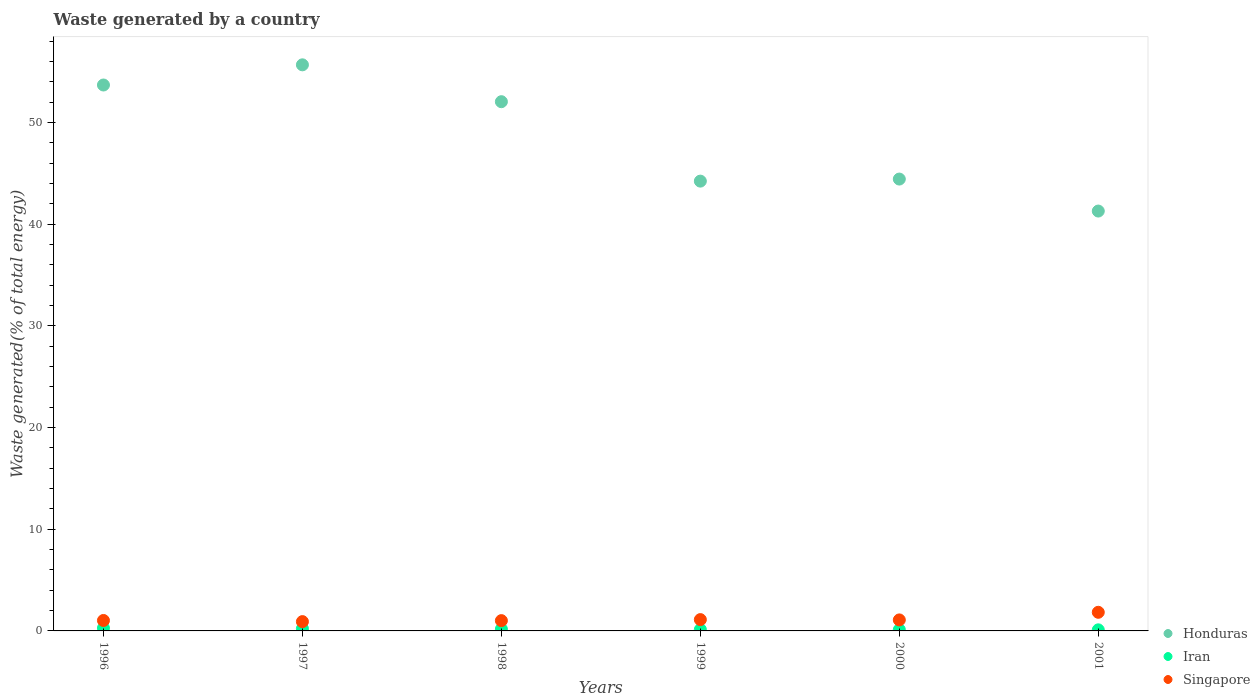How many different coloured dotlines are there?
Keep it short and to the point. 3. Is the number of dotlines equal to the number of legend labels?
Offer a very short reply. Yes. What is the total waste generated in Honduras in 2000?
Offer a terse response. 44.44. Across all years, what is the maximum total waste generated in Singapore?
Give a very brief answer. 1.83. Across all years, what is the minimum total waste generated in Singapore?
Offer a terse response. 0.91. In which year was the total waste generated in Singapore maximum?
Make the answer very short. 2001. In which year was the total waste generated in Singapore minimum?
Offer a terse response. 1997. What is the total total waste generated in Singapore in the graph?
Your answer should be compact. 6.98. What is the difference between the total waste generated in Honduras in 1997 and that in 1998?
Make the answer very short. 3.63. What is the difference between the total waste generated in Singapore in 1998 and the total waste generated in Honduras in 1996?
Your response must be concise. -52.67. What is the average total waste generated in Singapore per year?
Provide a short and direct response. 1.16. In the year 2000, what is the difference between the total waste generated in Singapore and total waste generated in Honduras?
Your answer should be very brief. -43.35. What is the ratio of the total waste generated in Singapore in 1997 to that in 2001?
Make the answer very short. 0.5. What is the difference between the highest and the second highest total waste generated in Singapore?
Your answer should be compact. 0.72. What is the difference between the highest and the lowest total waste generated in Iran?
Ensure brevity in your answer.  0.17. Is the sum of the total waste generated in Honduras in 1996 and 1998 greater than the maximum total waste generated in Singapore across all years?
Keep it short and to the point. Yes. Is it the case that in every year, the sum of the total waste generated in Honduras and total waste generated in Singapore  is greater than the total waste generated in Iran?
Provide a short and direct response. Yes. Does the total waste generated in Honduras monotonically increase over the years?
Provide a succinct answer. No. Is the total waste generated in Singapore strictly less than the total waste generated in Iran over the years?
Give a very brief answer. No. Are the values on the major ticks of Y-axis written in scientific E-notation?
Provide a succinct answer. No. How are the legend labels stacked?
Give a very brief answer. Vertical. What is the title of the graph?
Give a very brief answer. Waste generated by a country. What is the label or title of the X-axis?
Your answer should be compact. Years. What is the label or title of the Y-axis?
Give a very brief answer. Waste generated(% of total energy). What is the Waste generated(% of total energy) in Honduras in 1996?
Give a very brief answer. 53.69. What is the Waste generated(% of total energy) of Iran in 1996?
Offer a very short reply. 0.28. What is the Waste generated(% of total energy) in Singapore in 1996?
Your response must be concise. 1.03. What is the Waste generated(% of total energy) of Honduras in 1997?
Ensure brevity in your answer.  55.67. What is the Waste generated(% of total energy) in Iran in 1997?
Offer a terse response. 0.22. What is the Waste generated(% of total energy) of Singapore in 1997?
Make the answer very short. 0.91. What is the Waste generated(% of total energy) of Honduras in 1998?
Provide a succinct answer. 52.04. What is the Waste generated(% of total energy) in Iran in 1998?
Provide a short and direct response. 0.18. What is the Waste generated(% of total energy) of Singapore in 1998?
Your answer should be compact. 1.01. What is the Waste generated(% of total energy) in Honduras in 1999?
Ensure brevity in your answer.  44.23. What is the Waste generated(% of total energy) in Iran in 1999?
Your answer should be very brief. 0.14. What is the Waste generated(% of total energy) in Singapore in 1999?
Provide a short and direct response. 1.11. What is the Waste generated(% of total energy) of Honduras in 2000?
Provide a short and direct response. 44.44. What is the Waste generated(% of total energy) in Iran in 2000?
Your answer should be very brief. 0.12. What is the Waste generated(% of total energy) in Singapore in 2000?
Your answer should be very brief. 1.08. What is the Waste generated(% of total energy) in Honduras in 2001?
Provide a short and direct response. 41.29. What is the Waste generated(% of total energy) of Iran in 2001?
Keep it short and to the point. 0.11. What is the Waste generated(% of total energy) of Singapore in 2001?
Offer a terse response. 1.83. Across all years, what is the maximum Waste generated(% of total energy) of Honduras?
Provide a succinct answer. 55.67. Across all years, what is the maximum Waste generated(% of total energy) of Iran?
Make the answer very short. 0.28. Across all years, what is the maximum Waste generated(% of total energy) of Singapore?
Give a very brief answer. 1.83. Across all years, what is the minimum Waste generated(% of total energy) of Honduras?
Offer a very short reply. 41.29. Across all years, what is the minimum Waste generated(% of total energy) of Iran?
Make the answer very short. 0.11. Across all years, what is the minimum Waste generated(% of total energy) in Singapore?
Provide a short and direct response. 0.91. What is the total Waste generated(% of total energy) in Honduras in the graph?
Make the answer very short. 291.36. What is the total Waste generated(% of total energy) in Iran in the graph?
Provide a short and direct response. 1.05. What is the total Waste generated(% of total energy) of Singapore in the graph?
Your answer should be compact. 6.98. What is the difference between the Waste generated(% of total energy) in Honduras in 1996 and that in 1997?
Offer a terse response. -1.98. What is the difference between the Waste generated(% of total energy) in Iran in 1996 and that in 1997?
Give a very brief answer. 0.05. What is the difference between the Waste generated(% of total energy) in Singapore in 1996 and that in 1997?
Keep it short and to the point. 0.11. What is the difference between the Waste generated(% of total energy) in Honduras in 1996 and that in 1998?
Provide a short and direct response. 1.64. What is the difference between the Waste generated(% of total energy) of Iran in 1996 and that in 1998?
Your answer should be compact. 0.1. What is the difference between the Waste generated(% of total energy) of Singapore in 1996 and that in 1998?
Give a very brief answer. 0.02. What is the difference between the Waste generated(% of total energy) of Honduras in 1996 and that in 1999?
Provide a short and direct response. 9.45. What is the difference between the Waste generated(% of total energy) of Iran in 1996 and that in 1999?
Make the answer very short. 0.14. What is the difference between the Waste generated(% of total energy) in Singapore in 1996 and that in 1999?
Provide a short and direct response. -0.09. What is the difference between the Waste generated(% of total energy) in Honduras in 1996 and that in 2000?
Provide a short and direct response. 9.25. What is the difference between the Waste generated(% of total energy) in Iran in 1996 and that in 2000?
Your answer should be compact. 0.15. What is the difference between the Waste generated(% of total energy) of Singapore in 1996 and that in 2000?
Keep it short and to the point. -0.06. What is the difference between the Waste generated(% of total energy) in Honduras in 1996 and that in 2001?
Your response must be concise. 12.4. What is the difference between the Waste generated(% of total energy) in Iran in 1996 and that in 2001?
Provide a short and direct response. 0.17. What is the difference between the Waste generated(% of total energy) in Singapore in 1996 and that in 2001?
Provide a short and direct response. -0.8. What is the difference between the Waste generated(% of total energy) of Honduras in 1997 and that in 1998?
Ensure brevity in your answer.  3.63. What is the difference between the Waste generated(% of total energy) of Iran in 1997 and that in 1998?
Your answer should be compact. 0.05. What is the difference between the Waste generated(% of total energy) in Singapore in 1997 and that in 1998?
Provide a short and direct response. -0.1. What is the difference between the Waste generated(% of total energy) of Honduras in 1997 and that in 1999?
Keep it short and to the point. 11.44. What is the difference between the Waste generated(% of total energy) of Iran in 1997 and that in 1999?
Your answer should be very brief. 0.09. What is the difference between the Waste generated(% of total energy) in Singapore in 1997 and that in 1999?
Offer a very short reply. -0.2. What is the difference between the Waste generated(% of total energy) in Honduras in 1997 and that in 2000?
Your answer should be very brief. 11.23. What is the difference between the Waste generated(% of total energy) of Iran in 1997 and that in 2000?
Your answer should be compact. 0.1. What is the difference between the Waste generated(% of total energy) of Singapore in 1997 and that in 2000?
Keep it short and to the point. -0.17. What is the difference between the Waste generated(% of total energy) of Honduras in 1997 and that in 2001?
Offer a terse response. 14.38. What is the difference between the Waste generated(% of total energy) in Iran in 1997 and that in 2001?
Your answer should be compact. 0.12. What is the difference between the Waste generated(% of total energy) in Singapore in 1997 and that in 2001?
Give a very brief answer. -0.92. What is the difference between the Waste generated(% of total energy) in Honduras in 1998 and that in 1999?
Provide a succinct answer. 7.81. What is the difference between the Waste generated(% of total energy) of Iran in 1998 and that in 1999?
Offer a very short reply. 0.04. What is the difference between the Waste generated(% of total energy) of Singapore in 1998 and that in 1999?
Ensure brevity in your answer.  -0.1. What is the difference between the Waste generated(% of total energy) in Honduras in 1998 and that in 2000?
Ensure brevity in your answer.  7.61. What is the difference between the Waste generated(% of total energy) in Iran in 1998 and that in 2000?
Offer a terse response. 0.05. What is the difference between the Waste generated(% of total energy) in Singapore in 1998 and that in 2000?
Your response must be concise. -0.07. What is the difference between the Waste generated(% of total energy) in Honduras in 1998 and that in 2001?
Provide a short and direct response. 10.75. What is the difference between the Waste generated(% of total energy) in Iran in 1998 and that in 2001?
Give a very brief answer. 0.07. What is the difference between the Waste generated(% of total energy) of Singapore in 1998 and that in 2001?
Offer a terse response. -0.82. What is the difference between the Waste generated(% of total energy) of Honduras in 1999 and that in 2000?
Give a very brief answer. -0.2. What is the difference between the Waste generated(% of total energy) in Iran in 1999 and that in 2000?
Provide a short and direct response. 0.01. What is the difference between the Waste generated(% of total energy) of Singapore in 1999 and that in 2000?
Keep it short and to the point. 0.03. What is the difference between the Waste generated(% of total energy) in Honduras in 1999 and that in 2001?
Give a very brief answer. 2.94. What is the difference between the Waste generated(% of total energy) in Iran in 1999 and that in 2001?
Your answer should be compact. 0.03. What is the difference between the Waste generated(% of total energy) in Singapore in 1999 and that in 2001?
Offer a very short reply. -0.72. What is the difference between the Waste generated(% of total energy) in Honduras in 2000 and that in 2001?
Provide a succinct answer. 3.15. What is the difference between the Waste generated(% of total energy) in Iran in 2000 and that in 2001?
Ensure brevity in your answer.  0.02. What is the difference between the Waste generated(% of total energy) in Singapore in 2000 and that in 2001?
Your answer should be very brief. -0.75. What is the difference between the Waste generated(% of total energy) in Honduras in 1996 and the Waste generated(% of total energy) in Iran in 1997?
Your answer should be compact. 53.46. What is the difference between the Waste generated(% of total energy) in Honduras in 1996 and the Waste generated(% of total energy) in Singapore in 1997?
Provide a short and direct response. 52.77. What is the difference between the Waste generated(% of total energy) of Iran in 1996 and the Waste generated(% of total energy) of Singapore in 1997?
Your answer should be very brief. -0.64. What is the difference between the Waste generated(% of total energy) in Honduras in 1996 and the Waste generated(% of total energy) in Iran in 1998?
Offer a terse response. 53.51. What is the difference between the Waste generated(% of total energy) in Honduras in 1996 and the Waste generated(% of total energy) in Singapore in 1998?
Provide a succinct answer. 52.67. What is the difference between the Waste generated(% of total energy) of Iran in 1996 and the Waste generated(% of total energy) of Singapore in 1998?
Ensure brevity in your answer.  -0.73. What is the difference between the Waste generated(% of total energy) of Honduras in 1996 and the Waste generated(% of total energy) of Iran in 1999?
Make the answer very short. 53.55. What is the difference between the Waste generated(% of total energy) of Honduras in 1996 and the Waste generated(% of total energy) of Singapore in 1999?
Give a very brief answer. 52.57. What is the difference between the Waste generated(% of total energy) of Iran in 1996 and the Waste generated(% of total energy) of Singapore in 1999?
Provide a succinct answer. -0.83. What is the difference between the Waste generated(% of total energy) in Honduras in 1996 and the Waste generated(% of total energy) in Iran in 2000?
Provide a short and direct response. 53.56. What is the difference between the Waste generated(% of total energy) of Honduras in 1996 and the Waste generated(% of total energy) of Singapore in 2000?
Make the answer very short. 52.6. What is the difference between the Waste generated(% of total energy) of Iran in 1996 and the Waste generated(% of total energy) of Singapore in 2000?
Ensure brevity in your answer.  -0.8. What is the difference between the Waste generated(% of total energy) in Honduras in 1996 and the Waste generated(% of total energy) in Iran in 2001?
Give a very brief answer. 53.58. What is the difference between the Waste generated(% of total energy) in Honduras in 1996 and the Waste generated(% of total energy) in Singapore in 2001?
Provide a succinct answer. 51.85. What is the difference between the Waste generated(% of total energy) in Iran in 1996 and the Waste generated(% of total energy) in Singapore in 2001?
Ensure brevity in your answer.  -1.55. What is the difference between the Waste generated(% of total energy) in Honduras in 1997 and the Waste generated(% of total energy) in Iran in 1998?
Your answer should be very brief. 55.49. What is the difference between the Waste generated(% of total energy) in Honduras in 1997 and the Waste generated(% of total energy) in Singapore in 1998?
Offer a very short reply. 54.66. What is the difference between the Waste generated(% of total energy) of Iran in 1997 and the Waste generated(% of total energy) of Singapore in 1998?
Offer a very short reply. -0.79. What is the difference between the Waste generated(% of total energy) of Honduras in 1997 and the Waste generated(% of total energy) of Iran in 1999?
Ensure brevity in your answer.  55.53. What is the difference between the Waste generated(% of total energy) in Honduras in 1997 and the Waste generated(% of total energy) in Singapore in 1999?
Ensure brevity in your answer.  54.56. What is the difference between the Waste generated(% of total energy) of Iran in 1997 and the Waste generated(% of total energy) of Singapore in 1999?
Make the answer very short. -0.89. What is the difference between the Waste generated(% of total energy) of Honduras in 1997 and the Waste generated(% of total energy) of Iran in 2000?
Give a very brief answer. 55.55. What is the difference between the Waste generated(% of total energy) in Honduras in 1997 and the Waste generated(% of total energy) in Singapore in 2000?
Ensure brevity in your answer.  54.59. What is the difference between the Waste generated(% of total energy) of Iran in 1997 and the Waste generated(% of total energy) of Singapore in 2000?
Make the answer very short. -0.86. What is the difference between the Waste generated(% of total energy) in Honduras in 1997 and the Waste generated(% of total energy) in Iran in 2001?
Give a very brief answer. 55.56. What is the difference between the Waste generated(% of total energy) in Honduras in 1997 and the Waste generated(% of total energy) in Singapore in 2001?
Offer a very short reply. 53.84. What is the difference between the Waste generated(% of total energy) of Iran in 1997 and the Waste generated(% of total energy) of Singapore in 2001?
Provide a succinct answer. -1.61. What is the difference between the Waste generated(% of total energy) in Honduras in 1998 and the Waste generated(% of total energy) in Iran in 1999?
Provide a succinct answer. 51.91. What is the difference between the Waste generated(% of total energy) in Honduras in 1998 and the Waste generated(% of total energy) in Singapore in 1999?
Make the answer very short. 50.93. What is the difference between the Waste generated(% of total energy) in Iran in 1998 and the Waste generated(% of total energy) in Singapore in 1999?
Keep it short and to the point. -0.94. What is the difference between the Waste generated(% of total energy) of Honduras in 1998 and the Waste generated(% of total energy) of Iran in 2000?
Your answer should be very brief. 51.92. What is the difference between the Waste generated(% of total energy) in Honduras in 1998 and the Waste generated(% of total energy) in Singapore in 2000?
Offer a terse response. 50.96. What is the difference between the Waste generated(% of total energy) in Iran in 1998 and the Waste generated(% of total energy) in Singapore in 2000?
Your answer should be compact. -0.9. What is the difference between the Waste generated(% of total energy) of Honduras in 1998 and the Waste generated(% of total energy) of Iran in 2001?
Ensure brevity in your answer.  51.94. What is the difference between the Waste generated(% of total energy) in Honduras in 1998 and the Waste generated(% of total energy) in Singapore in 2001?
Ensure brevity in your answer.  50.21. What is the difference between the Waste generated(% of total energy) in Iran in 1998 and the Waste generated(% of total energy) in Singapore in 2001?
Your response must be concise. -1.65. What is the difference between the Waste generated(% of total energy) in Honduras in 1999 and the Waste generated(% of total energy) in Iran in 2000?
Keep it short and to the point. 44.11. What is the difference between the Waste generated(% of total energy) in Honduras in 1999 and the Waste generated(% of total energy) in Singapore in 2000?
Make the answer very short. 43.15. What is the difference between the Waste generated(% of total energy) of Iran in 1999 and the Waste generated(% of total energy) of Singapore in 2000?
Provide a short and direct response. -0.94. What is the difference between the Waste generated(% of total energy) of Honduras in 1999 and the Waste generated(% of total energy) of Iran in 2001?
Your answer should be very brief. 44.13. What is the difference between the Waste generated(% of total energy) in Honduras in 1999 and the Waste generated(% of total energy) in Singapore in 2001?
Ensure brevity in your answer.  42.4. What is the difference between the Waste generated(% of total energy) of Iran in 1999 and the Waste generated(% of total energy) of Singapore in 2001?
Ensure brevity in your answer.  -1.69. What is the difference between the Waste generated(% of total energy) of Honduras in 2000 and the Waste generated(% of total energy) of Iran in 2001?
Offer a very short reply. 44.33. What is the difference between the Waste generated(% of total energy) in Honduras in 2000 and the Waste generated(% of total energy) in Singapore in 2001?
Make the answer very short. 42.6. What is the difference between the Waste generated(% of total energy) of Iran in 2000 and the Waste generated(% of total energy) of Singapore in 2001?
Your response must be concise. -1.71. What is the average Waste generated(% of total energy) in Honduras per year?
Offer a terse response. 48.56. What is the average Waste generated(% of total energy) of Iran per year?
Provide a succinct answer. 0.17. What is the average Waste generated(% of total energy) of Singapore per year?
Keep it short and to the point. 1.16. In the year 1996, what is the difference between the Waste generated(% of total energy) in Honduras and Waste generated(% of total energy) in Iran?
Provide a short and direct response. 53.41. In the year 1996, what is the difference between the Waste generated(% of total energy) of Honduras and Waste generated(% of total energy) of Singapore?
Your response must be concise. 52.66. In the year 1996, what is the difference between the Waste generated(% of total energy) of Iran and Waste generated(% of total energy) of Singapore?
Keep it short and to the point. -0.75. In the year 1997, what is the difference between the Waste generated(% of total energy) of Honduras and Waste generated(% of total energy) of Iran?
Offer a very short reply. 55.45. In the year 1997, what is the difference between the Waste generated(% of total energy) of Honduras and Waste generated(% of total energy) of Singapore?
Make the answer very short. 54.76. In the year 1997, what is the difference between the Waste generated(% of total energy) of Iran and Waste generated(% of total energy) of Singapore?
Keep it short and to the point. -0.69. In the year 1998, what is the difference between the Waste generated(% of total energy) of Honduras and Waste generated(% of total energy) of Iran?
Ensure brevity in your answer.  51.87. In the year 1998, what is the difference between the Waste generated(% of total energy) of Honduras and Waste generated(% of total energy) of Singapore?
Keep it short and to the point. 51.03. In the year 1998, what is the difference between the Waste generated(% of total energy) in Iran and Waste generated(% of total energy) in Singapore?
Provide a succinct answer. -0.83. In the year 1999, what is the difference between the Waste generated(% of total energy) in Honduras and Waste generated(% of total energy) in Iran?
Provide a short and direct response. 44.1. In the year 1999, what is the difference between the Waste generated(% of total energy) of Honduras and Waste generated(% of total energy) of Singapore?
Your response must be concise. 43.12. In the year 1999, what is the difference between the Waste generated(% of total energy) of Iran and Waste generated(% of total energy) of Singapore?
Ensure brevity in your answer.  -0.97. In the year 2000, what is the difference between the Waste generated(% of total energy) of Honduras and Waste generated(% of total energy) of Iran?
Give a very brief answer. 44.31. In the year 2000, what is the difference between the Waste generated(% of total energy) of Honduras and Waste generated(% of total energy) of Singapore?
Provide a succinct answer. 43.35. In the year 2000, what is the difference between the Waste generated(% of total energy) in Iran and Waste generated(% of total energy) in Singapore?
Provide a short and direct response. -0.96. In the year 2001, what is the difference between the Waste generated(% of total energy) in Honduras and Waste generated(% of total energy) in Iran?
Make the answer very short. 41.18. In the year 2001, what is the difference between the Waste generated(% of total energy) in Honduras and Waste generated(% of total energy) in Singapore?
Offer a terse response. 39.46. In the year 2001, what is the difference between the Waste generated(% of total energy) of Iran and Waste generated(% of total energy) of Singapore?
Offer a very short reply. -1.73. What is the ratio of the Waste generated(% of total energy) of Honduras in 1996 to that in 1997?
Provide a succinct answer. 0.96. What is the ratio of the Waste generated(% of total energy) of Iran in 1996 to that in 1997?
Provide a short and direct response. 1.24. What is the ratio of the Waste generated(% of total energy) in Singapore in 1996 to that in 1997?
Provide a succinct answer. 1.12. What is the ratio of the Waste generated(% of total energy) of Honduras in 1996 to that in 1998?
Your answer should be very brief. 1.03. What is the ratio of the Waste generated(% of total energy) of Iran in 1996 to that in 1998?
Provide a succinct answer. 1.57. What is the ratio of the Waste generated(% of total energy) in Honduras in 1996 to that in 1999?
Make the answer very short. 1.21. What is the ratio of the Waste generated(% of total energy) in Iran in 1996 to that in 1999?
Your response must be concise. 2.02. What is the ratio of the Waste generated(% of total energy) of Singapore in 1996 to that in 1999?
Provide a short and direct response. 0.92. What is the ratio of the Waste generated(% of total energy) of Honduras in 1996 to that in 2000?
Offer a terse response. 1.21. What is the ratio of the Waste generated(% of total energy) in Iran in 1996 to that in 2000?
Give a very brief answer. 2.24. What is the ratio of the Waste generated(% of total energy) in Singapore in 1996 to that in 2000?
Provide a succinct answer. 0.95. What is the ratio of the Waste generated(% of total energy) of Honduras in 1996 to that in 2001?
Ensure brevity in your answer.  1.3. What is the ratio of the Waste generated(% of total energy) of Iran in 1996 to that in 2001?
Ensure brevity in your answer.  2.61. What is the ratio of the Waste generated(% of total energy) of Singapore in 1996 to that in 2001?
Your response must be concise. 0.56. What is the ratio of the Waste generated(% of total energy) in Honduras in 1997 to that in 1998?
Offer a very short reply. 1.07. What is the ratio of the Waste generated(% of total energy) in Iran in 1997 to that in 1998?
Provide a short and direct response. 1.27. What is the ratio of the Waste generated(% of total energy) in Singapore in 1997 to that in 1998?
Your answer should be very brief. 0.9. What is the ratio of the Waste generated(% of total energy) of Honduras in 1997 to that in 1999?
Give a very brief answer. 1.26. What is the ratio of the Waste generated(% of total energy) of Iran in 1997 to that in 1999?
Ensure brevity in your answer.  1.63. What is the ratio of the Waste generated(% of total energy) of Singapore in 1997 to that in 1999?
Provide a succinct answer. 0.82. What is the ratio of the Waste generated(% of total energy) of Honduras in 1997 to that in 2000?
Your response must be concise. 1.25. What is the ratio of the Waste generated(% of total energy) in Iran in 1997 to that in 2000?
Give a very brief answer. 1.8. What is the ratio of the Waste generated(% of total energy) of Singapore in 1997 to that in 2000?
Your answer should be very brief. 0.85. What is the ratio of the Waste generated(% of total energy) in Honduras in 1997 to that in 2001?
Offer a very short reply. 1.35. What is the ratio of the Waste generated(% of total energy) of Iran in 1997 to that in 2001?
Give a very brief answer. 2.11. What is the ratio of the Waste generated(% of total energy) of Singapore in 1997 to that in 2001?
Ensure brevity in your answer.  0.5. What is the ratio of the Waste generated(% of total energy) in Honduras in 1998 to that in 1999?
Keep it short and to the point. 1.18. What is the ratio of the Waste generated(% of total energy) in Iran in 1998 to that in 1999?
Your response must be concise. 1.29. What is the ratio of the Waste generated(% of total energy) of Singapore in 1998 to that in 1999?
Provide a succinct answer. 0.91. What is the ratio of the Waste generated(% of total energy) of Honduras in 1998 to that in 2000?
Provide a succinct answer. 1.17. What is the ratio of the Waste generated(% of total energy) of Iran in 1998 to that in 2000?
Give a very brief answer. 1.43. What is the ratio of the Waste generated(% of total energy) in Singapore in 1998 to that in 2000?
Offer a very short reply. 0.94. What is the ratio of the Waste generated(% of total energy) in Honduras in 1998 to that in 2001?
Offer a terse response. 1.26. What is the ratio of the Waste generated(% of total energy) in Iran in 1998 to that in 2001?
Your response must be concise. 1.66. What is the ratio of the Waste generated(% of total energy) of Singapore in 1998 to that in 2001?
Keep it short and to the point. 0.55. What is the ratio of the Waste generated(% of total energy) of Honduras in 1999 to that in 2000?
Ensure brevity in your answer.  1. What is the ratio of the Waste generated(% of total energy) in Iran in 1999 to that in 2000?
Your answer should be compact. 1.11. What is the ratio of the Waste generated(% of total energy) of Singapore in 1999 to that in 2000?
Offer a very short reply. 1.03. What is the ratio of the Waste generated(% of total energy) of Honduras in 1999 to that in 2001?
Offer a very short reply. 1.07. What is the ratio of the Waste generated(% of total energy) of Iran in 1999 to that in 2001?
Offer a very short reply. 1.29. What is the ratio of the Waste generated(% of total energy) of Singapore in 1999 to that in 2001?
Provide a short and direct response. 0.61. What is the ratio of the Waste generated(% of total energy) in Honduras in 2000 to that in 2001?
Offer a terse response. 1.08. What is the ratio of the Waste generated(% of total energy) in Iran in 2000 to that in 2001?
Keep it short and to the point. 1.17. What is the ratio of the Waste generated(% of total energy) in Singapore in 2000 to that in 2001?
Your response must be concise. 0.59. What is the difference between the highest and the second highest Waste generated(% of total energy) of Honduras?
Give a very brief answer. 1.98. What is the difference between the highest and the second highest Waste generated(% of total energy) of Iran?
Ensure brevity in your answer.  0.05. What is the difference between the highest and the second highest Waste generated(% of total energy) of Singapore?
Provide a short and direct response. 0.72. What is the difference between the highest and the lowest Waste generated(% of total energy) in Honduras?
Make the answer very short. 14.38. What is the difference between the highest and the lowest Waste generated(% of total energy) in Iran?
Your answer should be very brief. 0.17. What is the difference between the highest and the lowest Waste generated(% of total energy) in Singapore?
Ensure brevity in your answer.  0.92. 